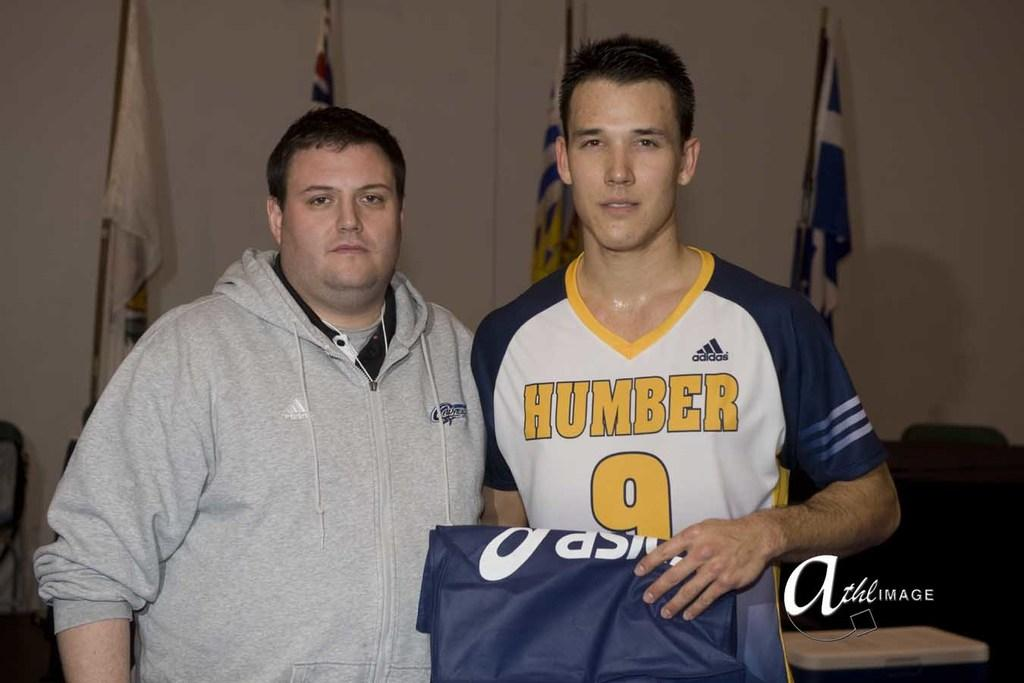Provide a one-sentence caption for the provided image. 2 men one wearing a jersey that reads humber 9. 